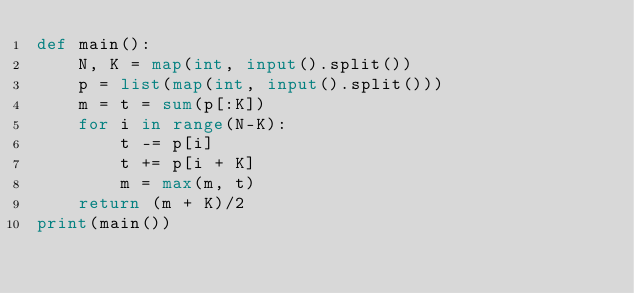Convert code to text. <code><loc_0><loc_0><loc_500><loc_500><_Python_>def main():
    N, K = map(int, input().split())
    p = list(map(int, input().split()))
    m = t = sum(p[:K])
    for i in range(N-K):
        t -= p[i]
        t += p[i + K]
        m = max(m, t)
    return (m + K)/2
print(main())
</code> 